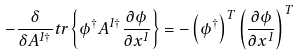Convert formula to latex. <formula><loc_0><loc_0><loc_500><loc_500>- \frac { \delta } { \delta A ^ { 1 \dagger } } t r \left \{ \phi ^ { \dagger } A ^ { 1 \dagger } \frac { \partial \phi } { \partial x ^ { 1 } } \right \} = - \left ( \phi ^ { \dagger } \right ) ^ { T } \left ( \frac { \partial \phi } { \partial x ^ { 1 } } \right ) ^ { T }</formula> 